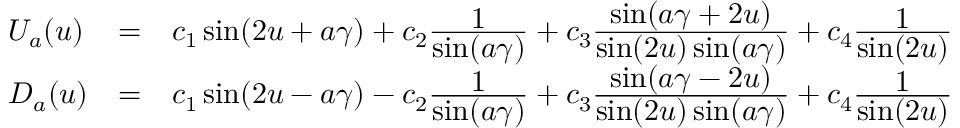<formula> <loc_0><loc_0><loc_500><loc_500>\begin{array} { l c l } { { U _ { a } ( u ) } } & { = } & { { c _ { 1 } \sin ( 2 u + a \gamma ) + c _ { 2 } \frac { 1 } { \sin ( a \gamma ) } + c _ { 3 } \frac { \sin ( a \gamma + 2 u ) } { \sin ( 2 u ) \sin ( a \gamma ) } + c _ { 4 } \frac { 1 } { \sin ( 2 u ) } } } \\ { { D _ { a } ( u ) } } & { = } & { { c _ { 1 } \sin ( 2 u - a \gamma ) - c _ { 2 } \frac { 1 } { \sin ( a \gamma ) } + c _ { 3 } \frac { \sin ( a \gamma - 2 u ) } { \sin ( 2 u ) \sin ( a \gamma ) } + c _ { 4 } \frac { 1 } { \sin ( 2 u ) } } } \end{array}</formula> 